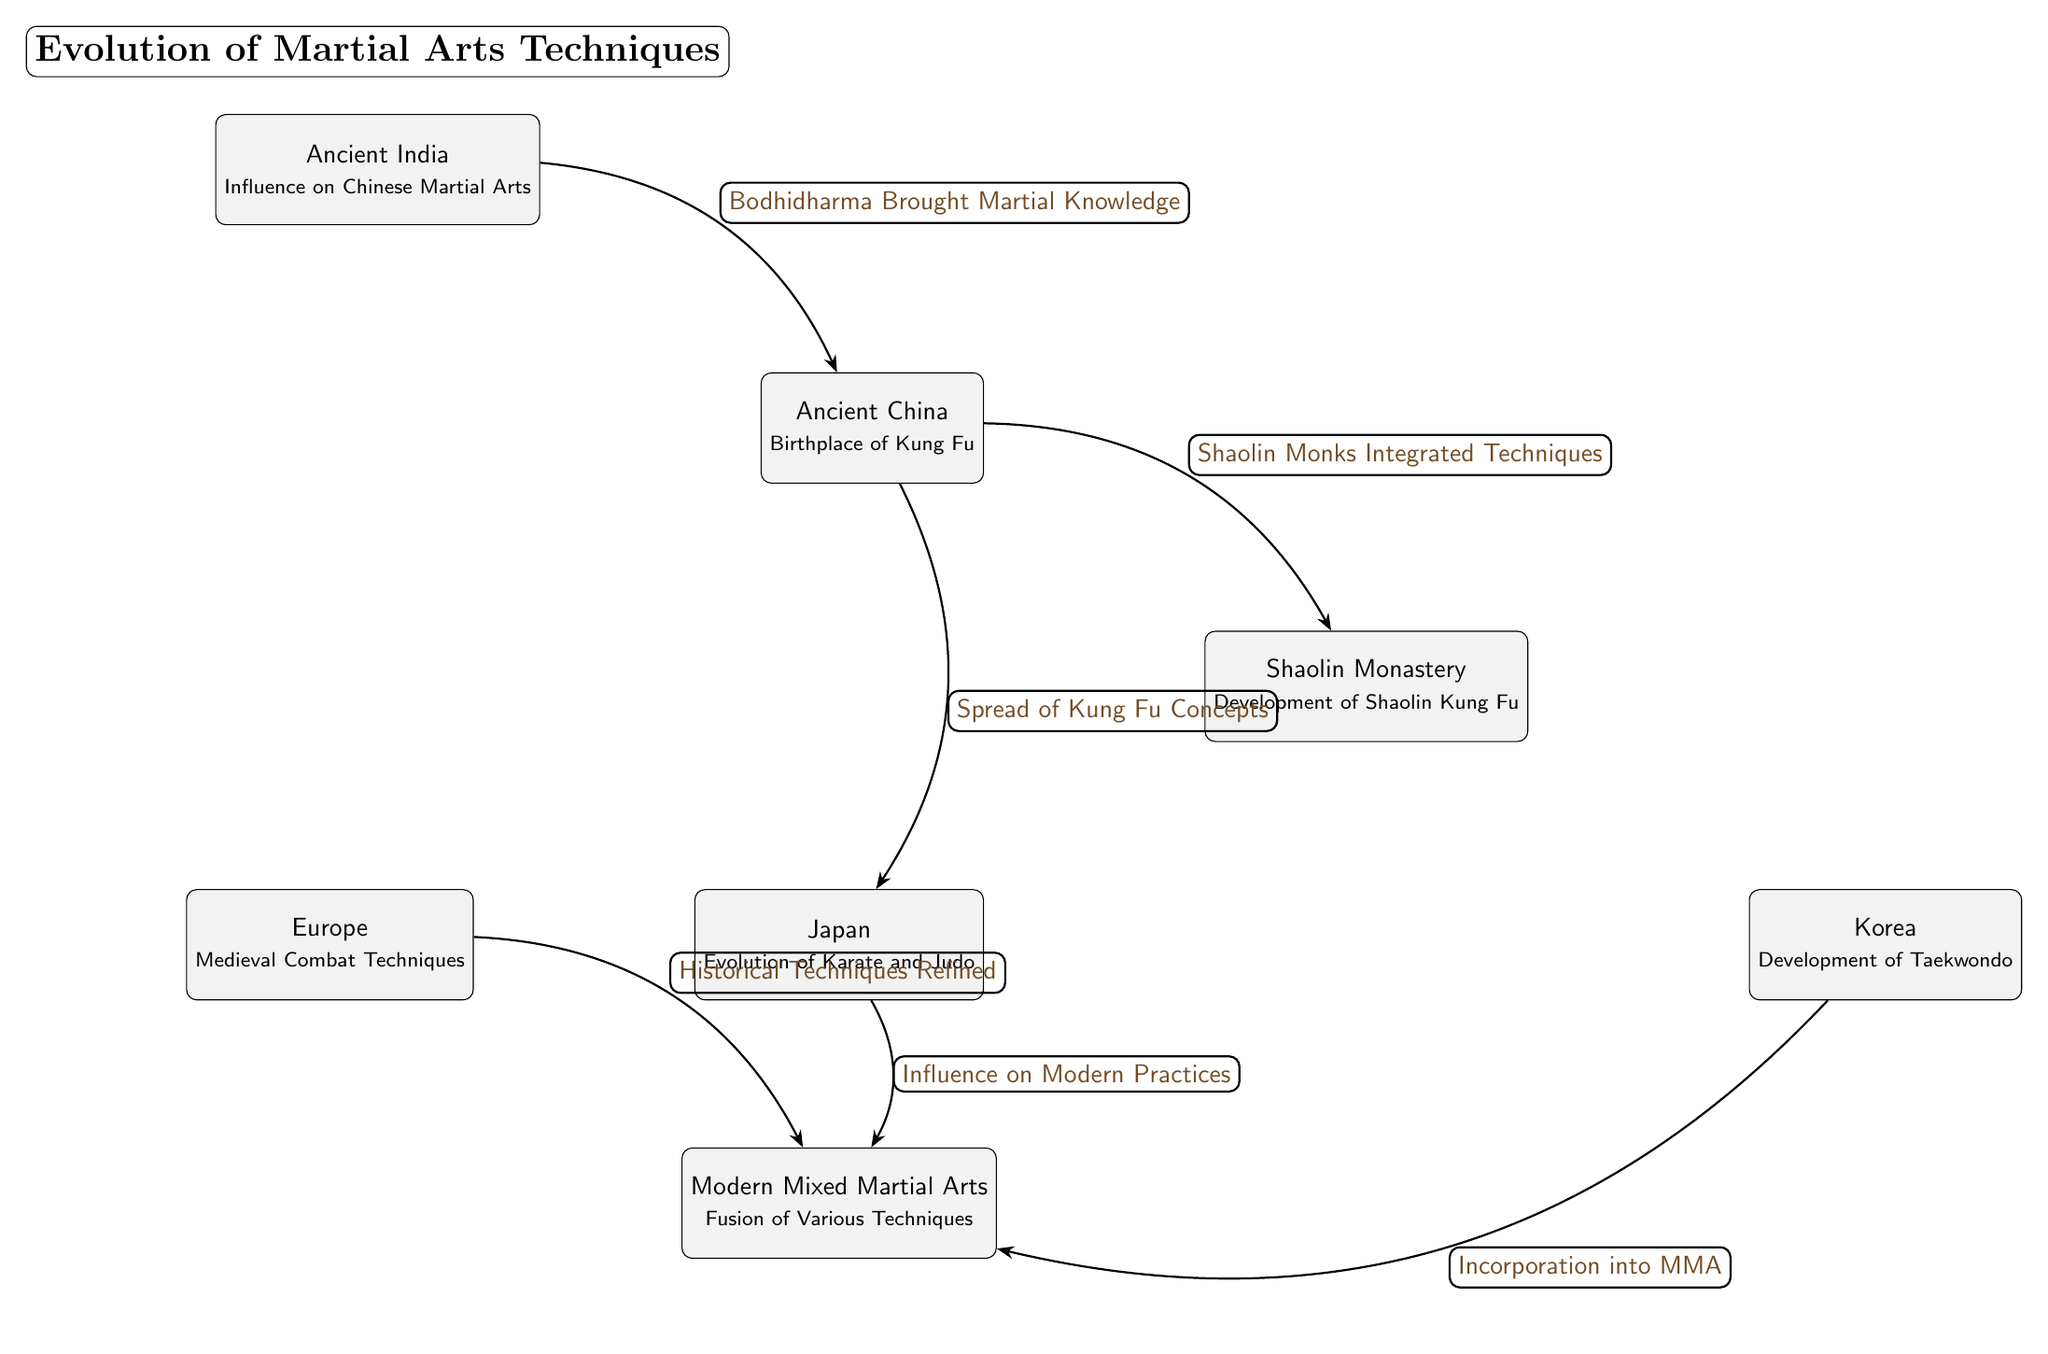What is the birthplace of Kung Fu? The diagram indicates that Ancient China is the birthplace of Kung Fu. This information is derived from the label on the node representing Ancient China.
Answer: Ancient China Which martial art developed from the Shaolin Monastery? The diagram states that the development of Shaolin Kung Fu is associated with the Shaolin Monastery. Thus, the answer is found in the description of that node.
Answer: Shaolin Kung Fu How many main nodes are depicted in the diagram? By counting the number of unique Cultural Nodes represented in the diagram, which are Ancient China, Shaolin Monastery, Ancient India, Japan, Korea, Europe, and Modern Mixed Martial Arts, we find that there are seven nodes in total.
Answer: 7 What influenced the evolution of Karate and Judo? The relationship illustrated in the diagram shows that the influence on Karate and Judo comes from the spread of Kung Fu concepts from Ancient China according to the directed edge leading to Japan.
Answer: Spread of Kung Fu Concepts What connections exist between Modern Mixed Martial Arts and other martial arts? Several connections exist: Modern Mixed Martial Arts is influenced by Karate and Judo from Japan, Taekwondo from Korea, and Medieval Combat Techniques from Europe, indicating that it is a fusion of techniques from these sources. This is gathered by reviewing the directed edges leading to the Modern Mixed Martial Arts node.
Answer: Karate and Judo, Taekwondo, Medieval Combat Techniques 